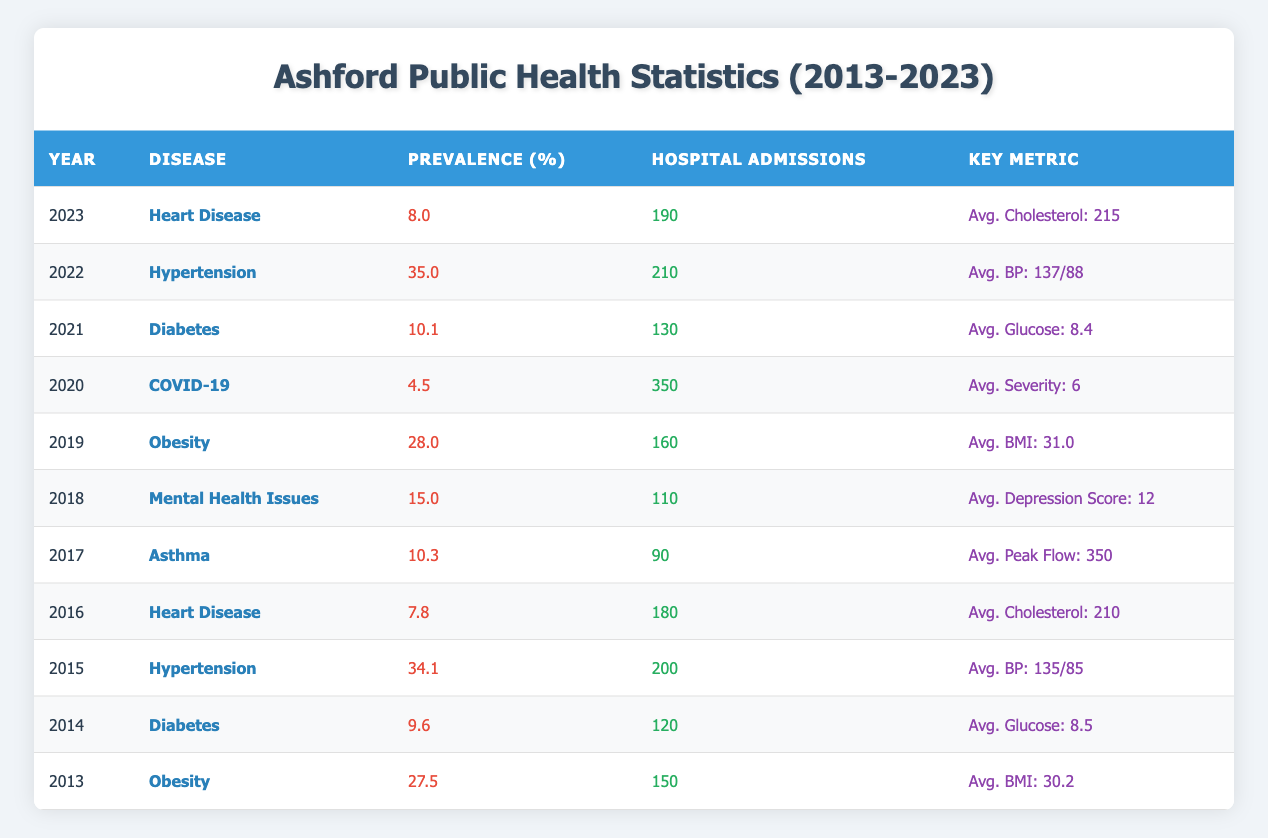What was the prevalence percentage of diabetes in Ashford in 2014? The table shows that the prevalence percentage of diabetes in Ashford in 2014 is listed under the row for that year. The value is 9.6%.
Answer: 9.6% In which year did obesity have the highest prevalence percentage between 2013 and 2019? Looking at the rows for obesity from 2013 to 2019, the values are 27.5% in 2013 and 28.0% in 2019. The highest percentage is therefore in 2019.
Answer: 28.0% What is the average hospital admissions for mental health issues and asthma combined? The hospital admissions for mental health issues in 2018 are 110, and for asthma in 2017 are 90. Summing these gives 110 + 90 = 200. Dividing by 2 for the average gives 200 / 2 = 100.
Answer: 100 Did the average blood pressure increase from 2015 to 2022? The average blood pressure in 2015 is 135/85, while in 2022 it is 137/88. Comparing these, we see that both the systolic (from 135 to 137) and diastolic (from 85 to 88) values increased, hence the average blood pressure did increase.
Answer: Yes What was the total number of hospital admissions for obesity from 2013 to 2019? The table shows the hospital admissions for obesity as follows: 150 in 2013 and 160 in 2019. Since there are no other years listed for obesity within this range, summing these gives 150 + 160 = 310.
Answer: 310 How did the prevalence of hypertension in 2022 compare to that in 2015? In 2015, the prevalence of hypertension was 34.1%, while in 2022 it increased to 35.0%. Thus, there is an increase in prevalence between these two years.
Answer: Increased What is the average BMI recorded for obesity from 2013 to 2019? From the table, the average BMI for obesity is 30.2 in 2013 and 31.0 in 2019. To find the average, sum these values (30.2 + 31.0 = 61.2) and divide by 2, giving 61.2 / 2 = 30.6.
Answer: 30.6 Was there a decrease in the prevalence of heart disease from 2016 to 2023? The prevalence of heart disease was 7.8% in 2016 and then decreased to 8.0% in 2023. This indicates an increase, not a decrease.
Answer: No 